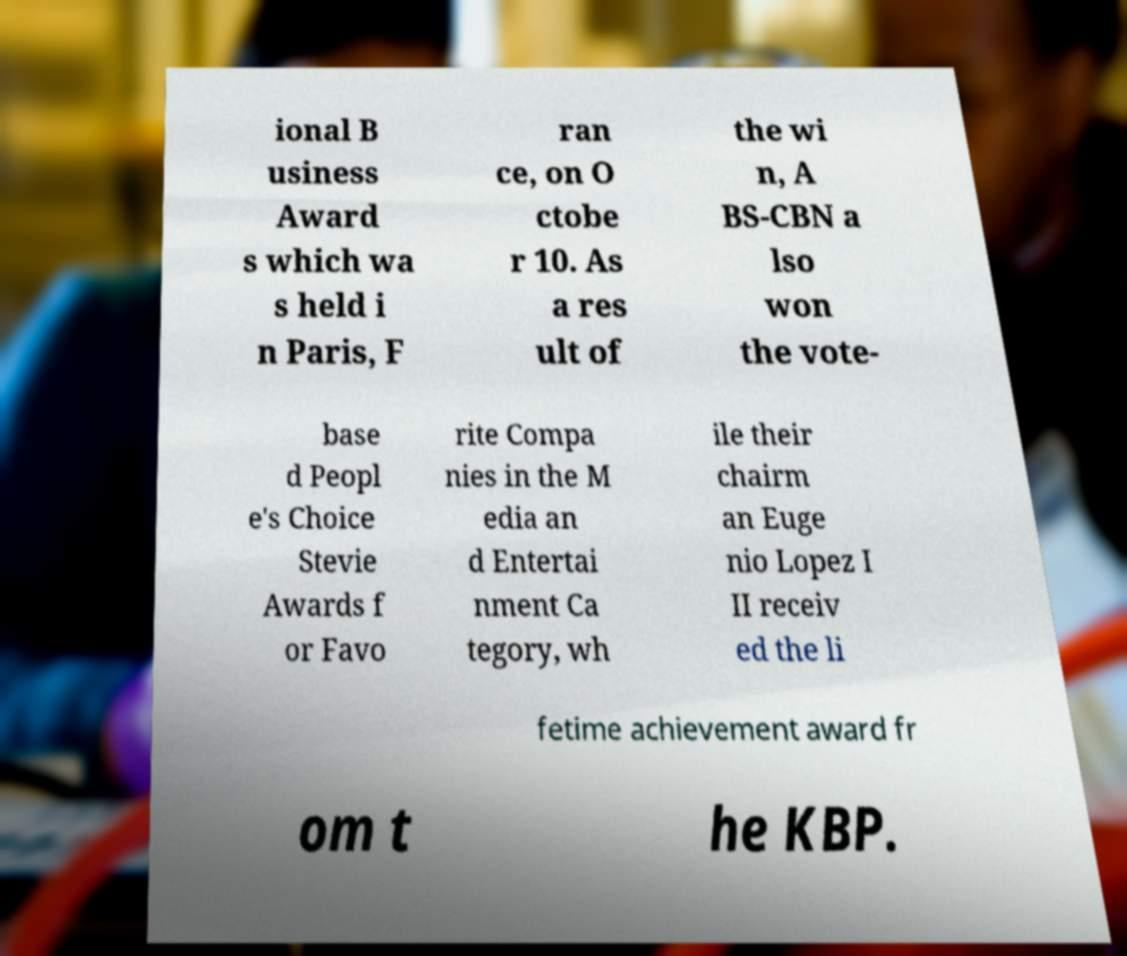There's text embedded in this image that I need extracted. Can you transcribe it verbatim? ional B usiness Award s which wa s held i n Paris, F ran ce, on O ctobe r 10. As a res ult of the wi n, A BS-CBN a lso won the vote- base d Peopl e's Choice Stevie Awards f or Favo rite Compa nies in the M edia an d Entertai nment Ca tegory, wh ile their chairm an Euge nio Lopez I II receiv ed the li fetime achievement award fr om t he KBP. 